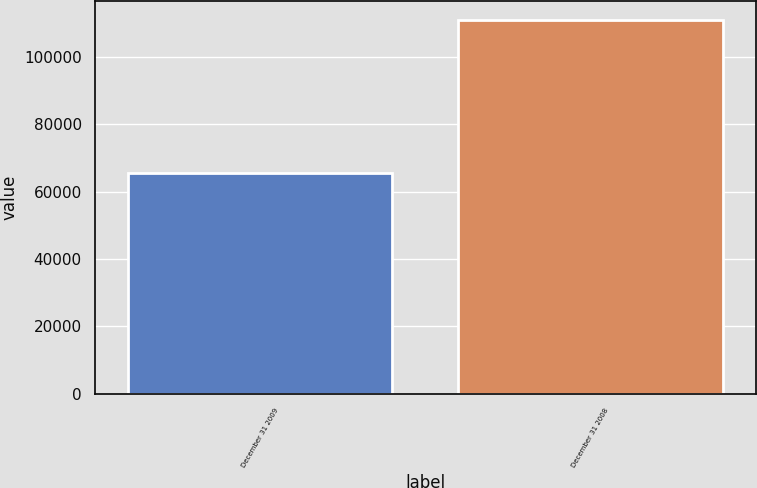<chart> <loc_0><loc_0><loc_500><loc_500><bar_chart><fcel>December 31 2009<fcel>December 31 2008<nl><fcel>65608<fcel>110919<nl></chart> 